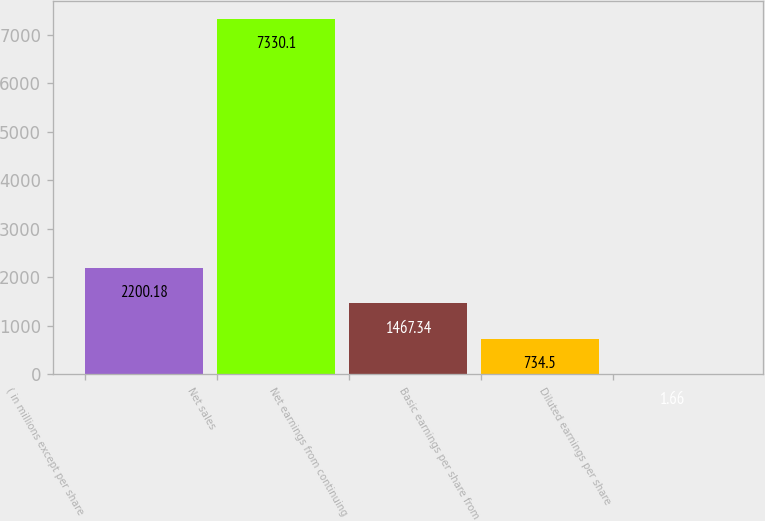Convert chart. <chart><loc_0><loc_0><loc_500><loc_500><bar_chart><fcel>( in millions except per share<fcel>Net sales<fcel>Net earnings from continuing<fcel>Basic earnings per share from<fcel>Diluted earnings per share<nl><fcel>2200.18<fcel>7330.1<fcel>1467.34<fcel>734.5<fcel>1.66<nl></chart> 